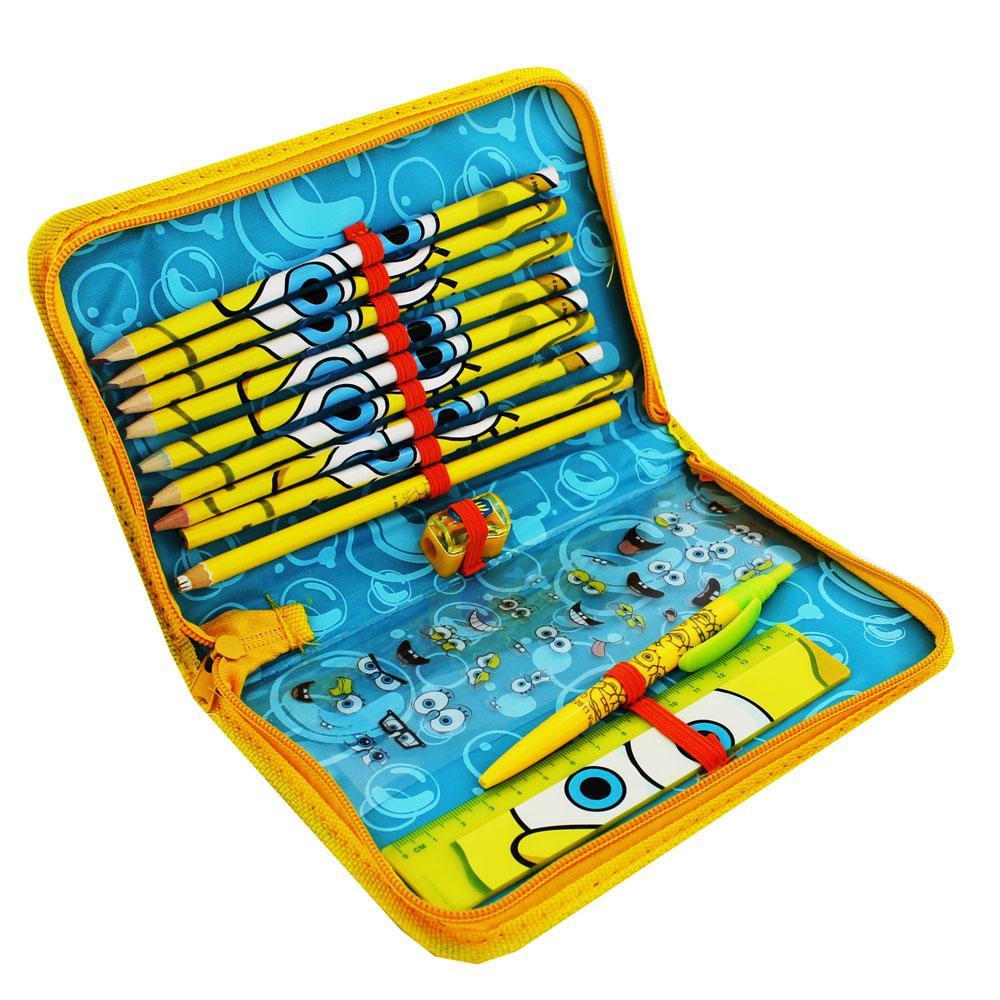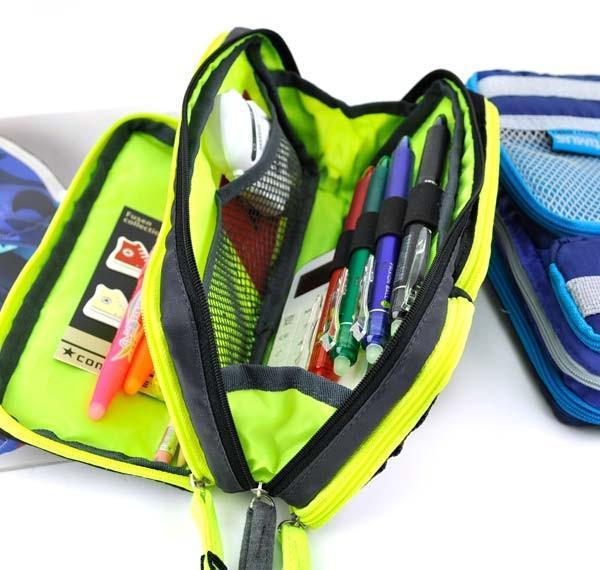The first image is the image on the left, the second image is the image on the right. For the images displayed, is the sentence "Only two pencil cases are visible in the pair of images." factually correct? Answer yes or no. No. The first image is the image on the left, the second image is the image on the right. Examine the images to the left and right. Is the description "There are more pencil cases in the image on the right." accurate? Answer yes or no. Yes. 